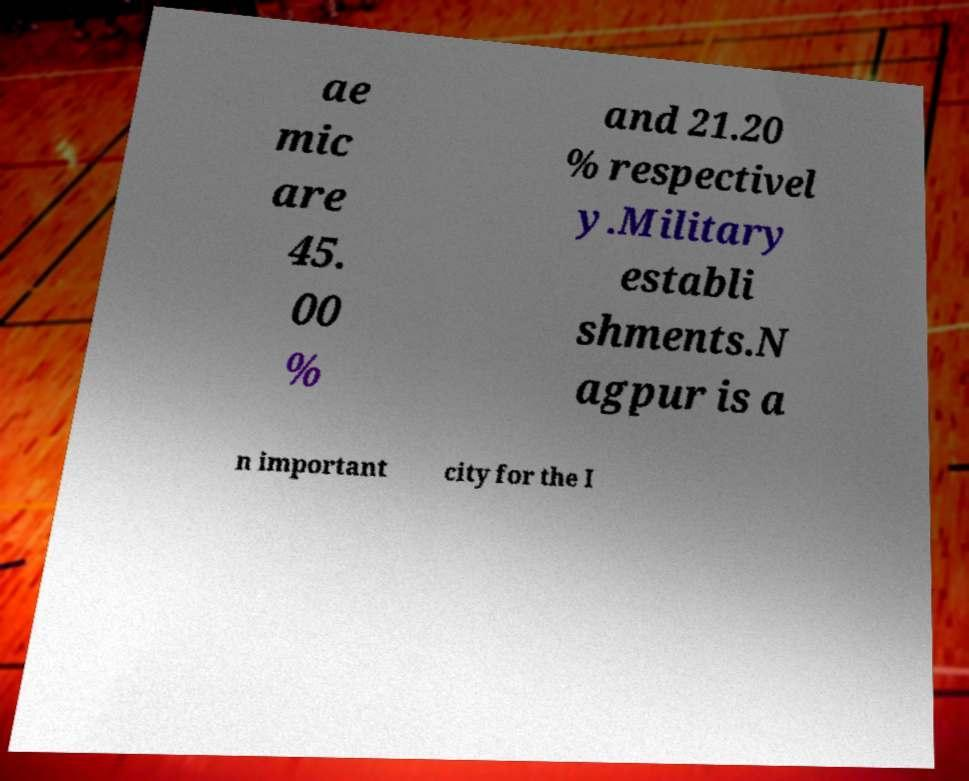Please read and relay the text visible in this image. What does it say? ae mic are 45. 00 % and 21.20 % respectivel y.Military establi shments.N agpur is a n important city for the I 